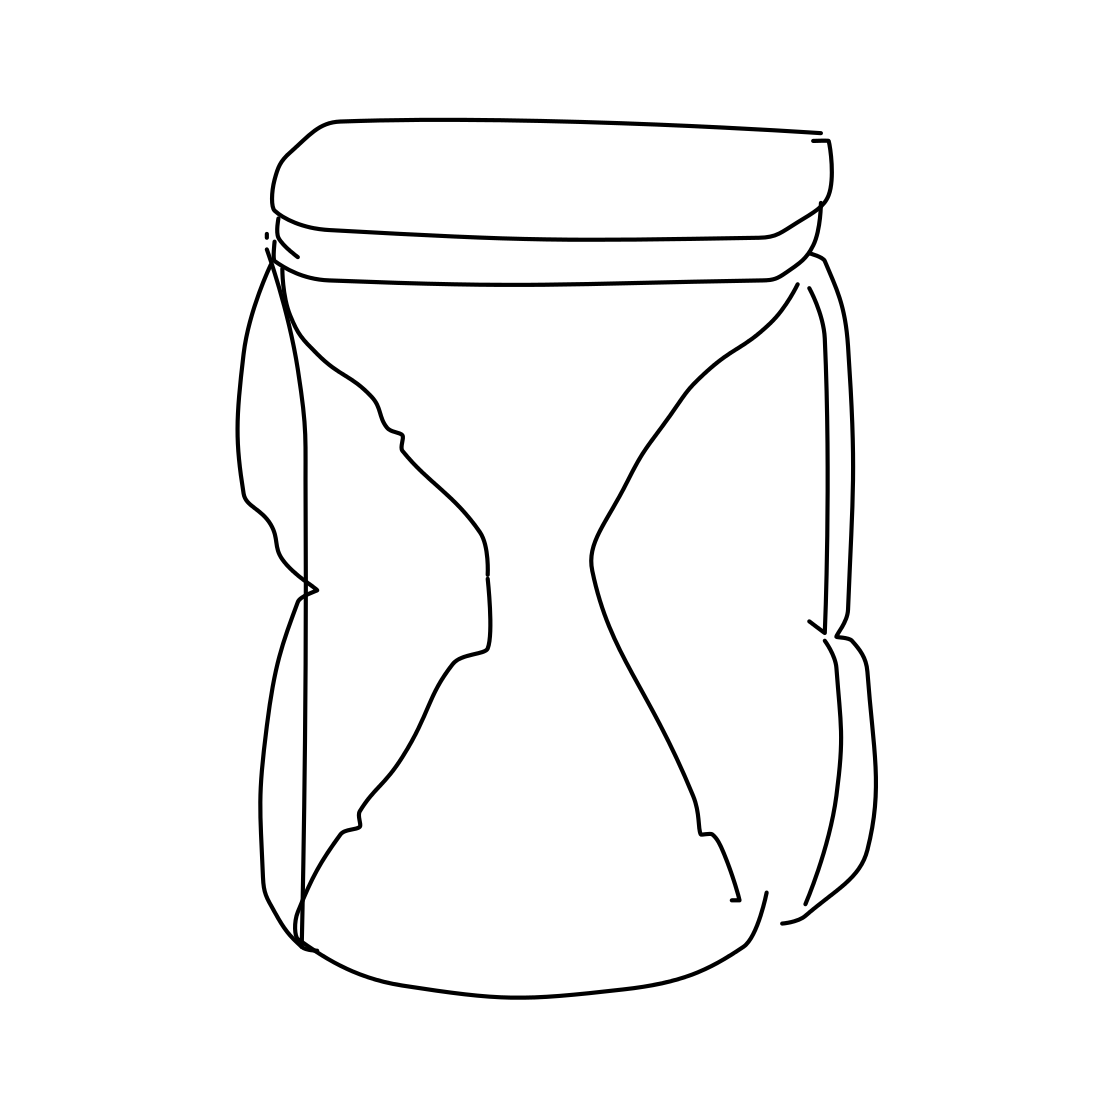Can you describe the object in this picture? The image shows a line drawing of a jar that appears to be empty. It has a quirky, whimsical quality to it with its squeezed-like shape. There's a simplicity to the sketch that suggests it could be a concept or a minimalist piece of art. 